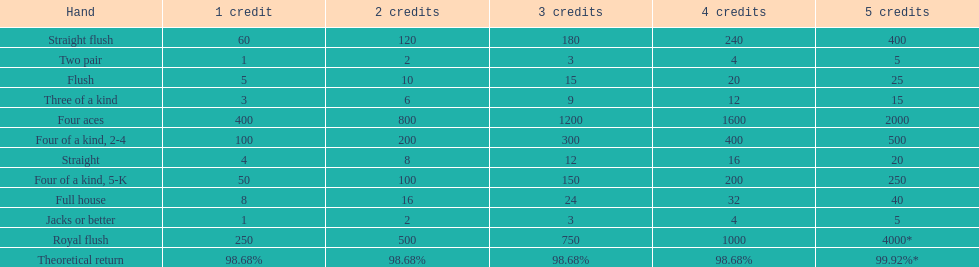The number of credits returned for a one credit bet on a royal flush are. 250. Give me the full table as a dictionary. {'header': ['Hand', '1 credit', '2 credits', '3 credits', '4 credits', '5 credits'], 'rows': [['Straight flush', '60', '120', '180', '240', '400'], ['Two pair', '1', '2', '3', '4', '5'], ['Flush', '5', '10', '15', '20', '25'], ['Three of a kind', '3', '6', '9', '12', '15'], ['Four aces', '400', '800', '1200', '1600', '2000'], ['Four of a kind, 2-4', '100', '200', '300', '400', '500'], ['Straight', '4', '8', '12', '16', '20'], ['Four of a kind, 5-K', '50', '100', '150', '200', '250'], ['Full house', '8', '16', '24', '32', '40'], ['Jacks or better', '1', '2', '3', '4', '5'], ['Royal flush', '250', '500', '750', '1000', '4000*'], ['Theoretical return', '98.68%', '98.68%', '98.68%', '98.68%', '99.92%*']]} 